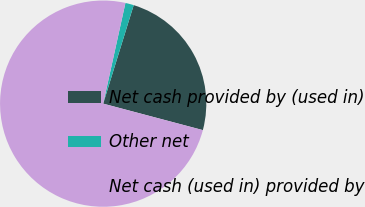<chart> <loc_0><loc_0><loc_500><loc_500><pie_chart><fcel>Net cash provided by (used in)<fcel>Other net<fcel>Net cash (used in) provided by<nl><fcel>24.35%<fcel>1.32%<fcel>74.33%<nl></chart> 